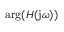Convert formula to latex. <formula><loc_0><loc_0><loc_500><loc_500>\arg ( H ( j \omega ) )</formula> 